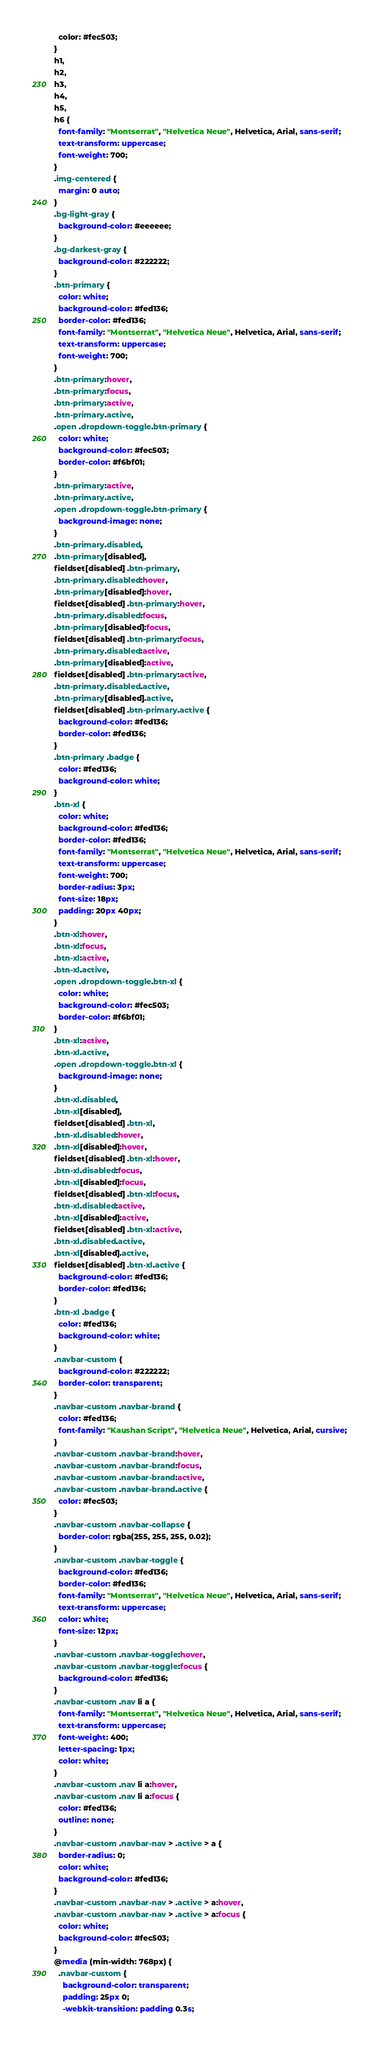<code> <loc_0><loc_0><loc_500><loc_500><_CSS_>  color: #fec503;
}
h1,
h2,
h3,
h4,
h5,
h6 {
  font-family: "Montserrat", "Helvetica Neue", Helvetica, Arial, sans-serif;
  text-transform: uppercase;
  font-weight: 700;
}
.img-centered {
  margin: 0 auto;
}
.bg-light-gray {
  background-color: #eeeeee;
}
.bg-darkest-gray {
  background-color: #222222;
}
.btn-primary {
  color: white;
  background-color: #fed136;
  border-color: #fed136;
  font-family: "Montserrat", "Helvetica Neue", Helvetica, Arial, sans-serif;
  text-transform: uppercase;
  font-weight: 700;
}
.btn-primary:hover,
.btn-primary:focus,
.btn-primary:active,
.btn-primary.active,
.open .dropdown-toggle.btn-primary {
  color: white;
  background-color: #fec503;
  border-color: #f6bf01;
}
.btn-primary:active,
.btn-primary.active,
.open .dropdown-toggle.btn-primary {
  background-image: none;
}
.btn-primary.disabled,
.btn-primary[disabled],
fieldset[disabled] .btn-primary,
.btn-primary.disabled:hover,
.btn-primary[disabled]:hover,
fieldset[disabled] .btn-primary:hover,
.btn-primary.disabled:focus,
.btn-primary[disabled]:focus,
fieldset[disabled] .btn-primary:focus,
.btn-primary.disabled:active,
.btn-primary[disabled]:active,
fieldset[disabled] .btn-primary:active,
.btn-primary.disabled.active,
.btn-primary[disabled].active,
fieldset[disabled] .btn-primary.active {
  background-color: #fed136;
  border-color: #fed136;
}
.btn-primary .badge {
  color: #fed136;
  background-color: white;
}
.btn-xl {
  color: white;
  background-color: #fed136;
  border-color: #fed136;
  font-family: "Montserrat", "Helvetica Neue", Helvetica, Arial, sans-serif;
  text-transform: uppercase;
  font-weight: 700;
  border-radius: 3px;
  font-size: 18px;
  padding: 20px 40px;
}
.btn-xl:hover,
.btn-xl:focus,
.btn-xl:active,
.btn-xl.active,
.open .dropdown-toggle.btn-xl {
  color: white;
  background-color: #fec503;
  border-color: #f6bf01;
}
.btn-xl:active,
.btn-xl.active,
.open .dropdown-toggle.btn-xl {
  background-image: none;
}
.btn-xl.disabled,
.btn-xl[disabled],
fieldset[disabled] .btn-xl,
.btn-xl.disabled:hover,
.btn-xl[disabled]:hover,
fieldset[disabled] .btn-xl:hover,
.btn-xl.disabled:focus,
.btn-xl[disabled]:focus,
fieldset[disabled] .btn-xl:focus,
.btn-xl.disabled:active,
.btn-xl[disabled]:active,
fieldset[disabled] .btn-xl:active,
.btn-xl.disabled.active,
.btn-xl[disabled].active,
fieldset[disabled] .btn-xl.active {
  background-color: #fed136;
  border-color: #fed136;
}
.btn-xl .badge {
  color: #fed136;
  background-color: white;
}
.navbar-custom {
  background-color: #222222;
  border-color: transparent;
}
.navbar-custom .navbar-brand {
  color: #fed136;
  font-family: "Kaushan Script", "Helvetica Neue", Helvetica, Arial, cursive;
}
.navbar-custom .navbar-brand:hover,
.navbar-custom .navbar-brand:focus,
.navbar-custom .navbar-brand:active,
.navbar-custom .navbar-brand.active {
  color: #fec503;
}
.navbar-custom .navbar-collapse {
  border-color: rgba(255, 255, 255, 0.02);
}
.navbar-custom .navbar-toggle {
  background-color: #fed136;
  border-color: #fed136;
  font-family: "Montserrat", "Helvetica Neue", Helvetica, Arial, sans-serif;
  text-transform: uppercase;
  color: white;
  font-size: 12px;
}
.navbar-custom .navbar-toggle:hover,
.navbar-custom .navbar-toggle:focus {
  background-color: #fed136;
}
.navbar-custom .nav li a {
  font-family: "Montserrat", "Helvetica Neue", Helvetica, Arial, sans-serif;
  text-transform: uppercase;
  font-weight: 400;
  letter-spacing: 1px;
  color: white;
}
.navbar-custom .nav li a:hover,
.navbar-custom .nav li a:focus {
  color: #fed136;
  outline: none;
}
.navbar-custom .navbar-nav > .active > a {
  border-radius: 0;
  color: white;
  background-color: #fed136;
}
.navbar-custom .navbar-nav > .active > a:hover,
.navbar-custom .navbar-nav > .active > a:focus {
  color: white;
  background-color: #fec503;
}
@media (min-width: 768px) {
  .navbar-custom {
    background-color: transparent;
    padding: 25px 0;
    -webkit-transition: padding 0.3s;</code> 